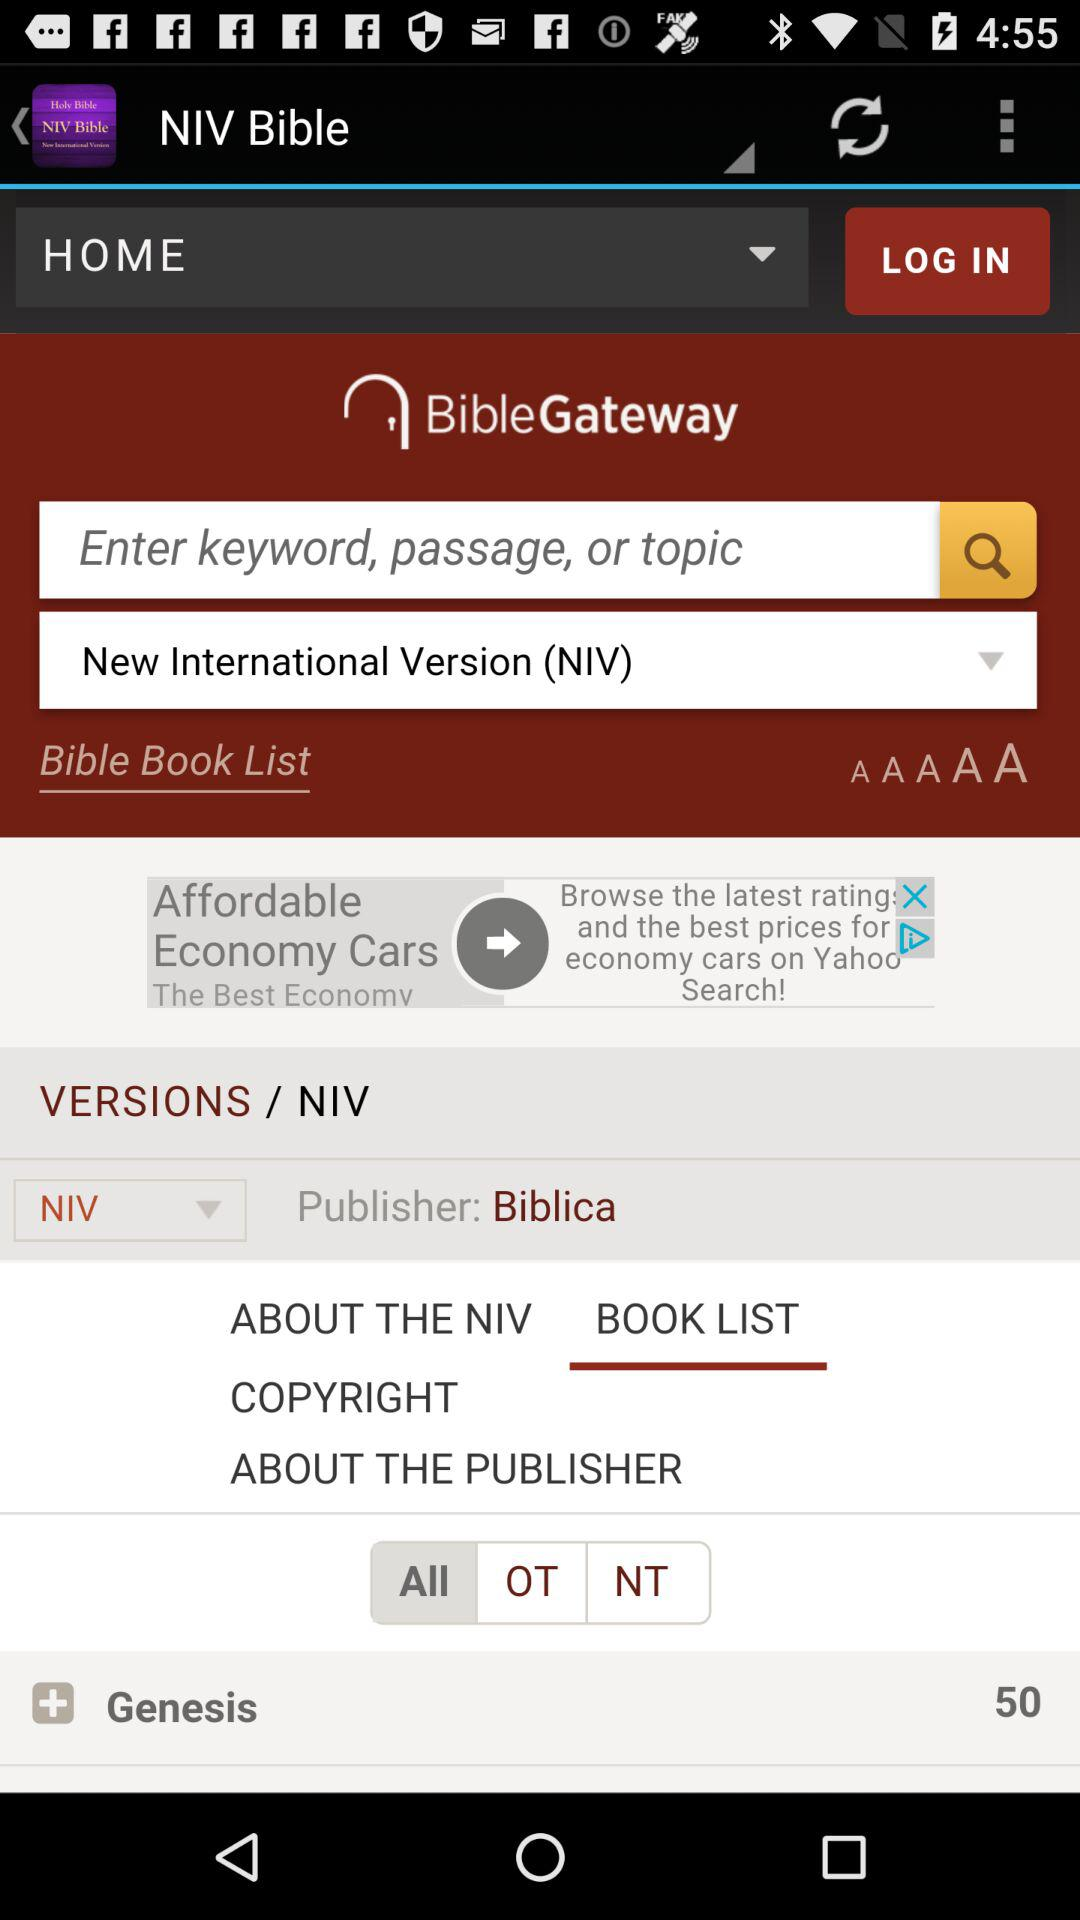Which tab is selected?
When the provided information is insufficient, respond with <no answer>. <no answer> 